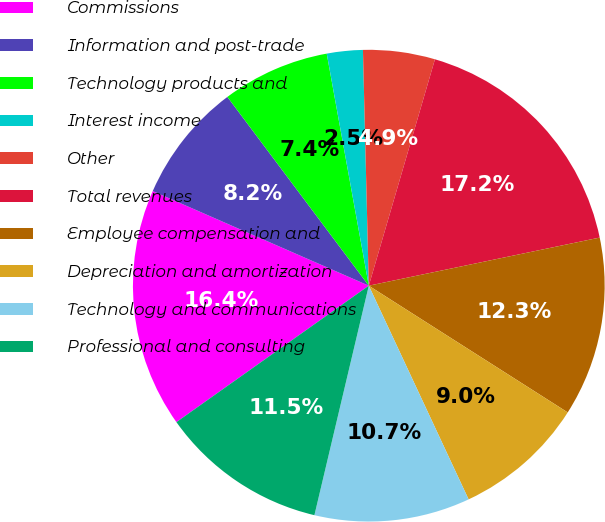<chart> <loc_0><loc_0><loc_500><loc_500><pie_chart><fcel>Commissions<fcel>Information and post-trade<fcel>Technology products and<fcel>Interest income<fcel>Other<fcel>Total revenues<fcel>Employee compensation and<fcel>Depreciation and amortization<fcel>Technology and communications<fcel>Professional and consulting<nl><fcel>16.39%<fcel>8.2%<fcel>7.38%<fcel>2.46%<fcel>4.92%<fcel>17.21%<fcel>12.3%<fcel>9.02%<fcel>10.66%<fcel>11.48%<nl></chart> 